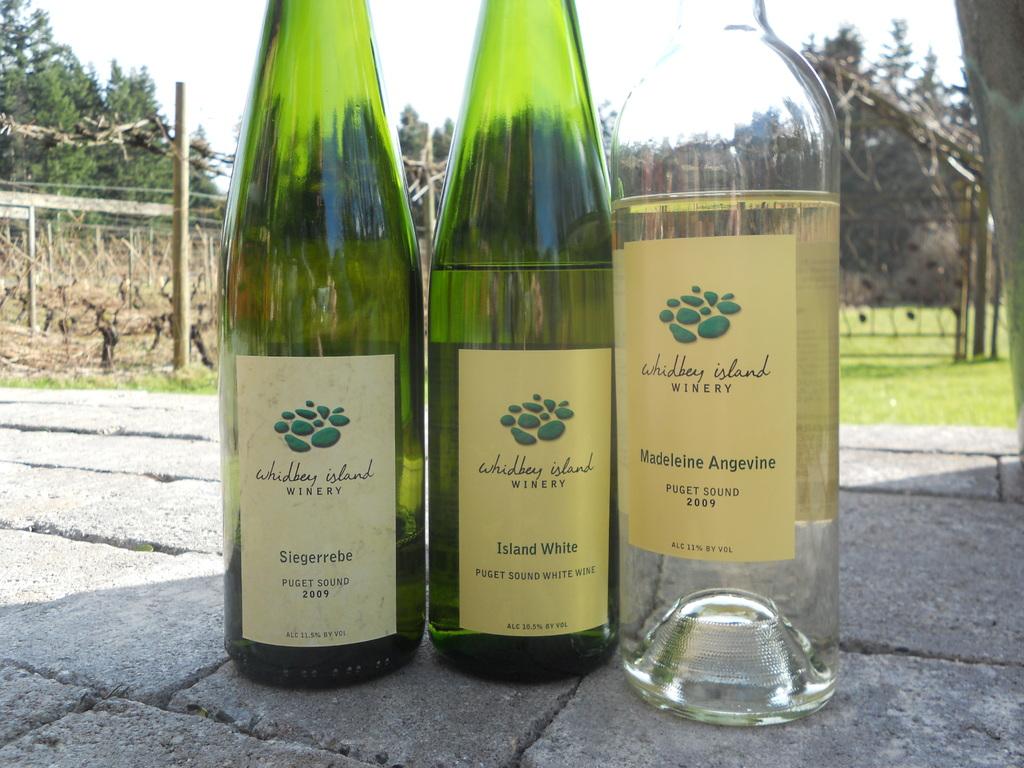From what island is the wine?
Your answer should be compact. Whidbey. 